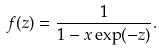Convert formula to latex. <formula><loc_0><loc_0><loc_500><loc_500>f ( z ) = \frac { 1 } { 1 - x \exp ( - z ) } .</formula> 